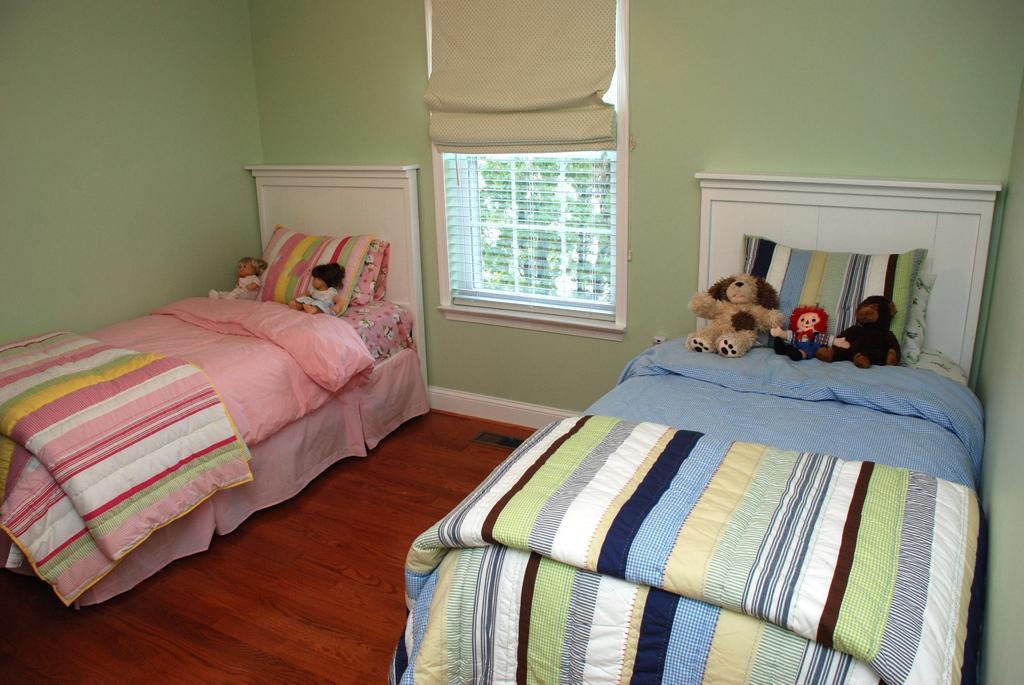In one or two sentences, can you explain what this image depicts? Here we can see two beds present with toys and pillows on it and between them there is a window 